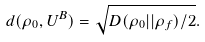Convert formula to latex. <formula><loc_0><loc_0><loc_500><loc_500>d ( \rho _ { 0 } , U ^ { B } ) = \sqrt { D ( \rho _ { 0 } | | \rho _ { f } ) / 2 } .</formula> 